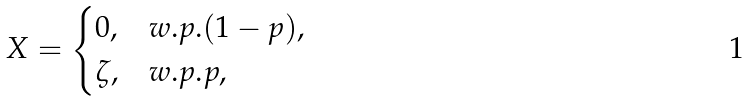<formula> <loc_0><loc_0><loc_500><loc_500>X = \begin{cases} 0 , & w . p . ( 1 - p ) , \\ \zeta , & w . p . p , \end{cases}</formula> 